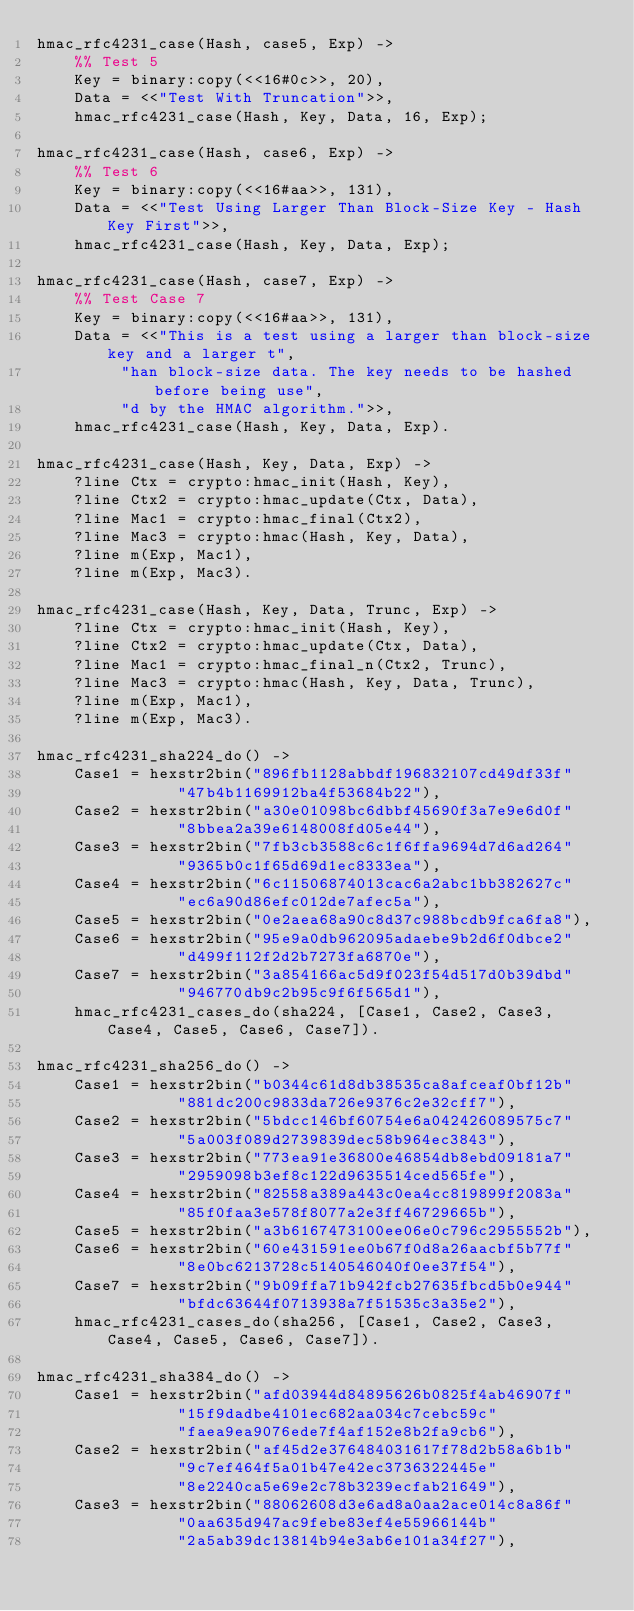<code> <loc_0><loc_0><loc_500><loc_500><_Erlang_>hmac_rfc4231_case(Hash, case5, Exp) ->
    %% Test 5
    Key = binary:copy(<<16#0c>>, 20),
    Data = <<"Test With Truncation">>,
    hmac_rfc4231_case(Hash, Key, Data, 16, Exp);

hmac_rfc4231_case(Hash, case6, Exp) ->
    %% Test 6
    Key = binary:copy(<<16#aa>>, 131),
    Data = <<"Test Using Larger Than Block-Size Key - Hash Key First">>,
    hmac_rfc4231_case(Hash, Key, Data, Exp);

hmac_rfc4231_case(Hash, case7, Exp) ->
    %% Test Case 7
    Key = binary:copy(<<16#aa>>, 131),
    Data = <<"This is a test using a larger than block-size key and a larger t",
	     "han block-size data. The key needs to be hashed before being use",
	     "d by the HMAC algorithm.">>,
    hmac_rfc4231_case(Hash, Key, Data, Exp).

hmac_rfc4231_case(Hash, Key, Data, Exp) ->
    ?line Ctx = crypto:hmac_init(Hash, Key),
    ?line Ctx2 = crypto:hmac_update(Ctx, Data),
    ?line Mac1 = crypto:hmac_final(Ctx2),
    ?line Mac3 = crypto:hmac(Hash, Key, Data),
    ?line m(Exp, Mac1),
    ?line m(Exp, Mac3).

hmac_rfc4231_case(Hash, Key, Data, Trunc, Exp) ->
    ?line Ctx = crypto:hmac_init(Hash, Key),
    ?line Ctx2 = crypto:hmac_update(Ctx, Data),
    ?line Mac1 = crypto:hmac_final_n(Ctx2, Trunc),
    ?line Mac3 = crypto:hmac(Hash, Key, Data, Trunc),
    ?line m(Exp, Mac1),
    ?line m(Exp, Mac3).

hmac_rfc4231_sha224_do() ->
    Case1 = hexstr2bin("896fb1128abbdf196832107cd49df33f"
		       "47b4b1169912ba4f53684b22"),
    Case2 = hexstr2bin("a30e01098bc6dbbf45690f3a7e9e6d0f"
		       "8bbea2a39e6148008fd05e44"),
    Case3 = hexstr2bin("7fb3cb3588c6c1f6ffa9694d7d6ad264"
		       "9365b0c1f65d69d1ec8333ea"),
    Case4 = hexstr2bin("6c11506874013cac6a2abc1bb382627c"
		       "ec6a90d86efc012de7afec5a"),
    Case5 = hexstr2bin("0e2aea68a90c8d37c988bcdb9fca6fa8"),
    Case6 = hexstr2bin("95e9a0db962095adaebe9b2d6f0dbce2"
		       "d499f112f2d2b7273fa6870e"),
    Case7 = hexstr2bin("3a854166ac5d9f023f54d517d0b39dbd"
		       "946770db9c2b95c9f6f565d1"),
    hmac_rfc4231_cases_do(sha224, [Case1, Case2, Case3, Case4, Case5, Case6, Case7]).

hmac_rfc4231_sha256_do() ->
    Case1 = hexstr2bin("b0344c61d8db38535ca8afceaf0bf12b"
		       "881dc200c9833da726e9376c2e32cff7"),
    Case2 = hexstr2bin("5bdcc146bf60754e6a042426089575c7"
		       "5a003f089d2739839dec58b964ec3843"),
    Case3 = hexstr2bin("773ea91e36800e46854db8ebd09181a7"
		       "2959098b3ef8c122d9635514ced565fe"),
    Case4 = hexstr2bin("82558a389a443c0ea4cc819899f2083a"
		       "85f0faa3e578f8077a2e3ff46729665b"),
    Case5 = hexstr2bin("a3b6167473100ee06e0c796c2955552b"),
    Case6 = hexstr2bin("60e431591ee0b67f0d8a26aacbf5b77f"
		       "8e0bc6213728c5140546040f0ee37f54"),
    Case7 = hexstr2bin("9b09ffa71b942fcb27635fbcd5b0e944"
		       "bfdc63644f0713938a7f51535c3a35e2"),
    hmac_rfc4231_cases_do(sha256, [Case1, Case2, Case3, Case4, Case5, Case6, Case7]).

hmac_rfc4231_sha384_do() ->
    Case1 = hexstr2bin("afd03944d84895626b0825f4ab46907f"
		       "15f9dadbe4101ec682aa034c7cebc59c"
		       "faea9ea9076ede7f4af152e8b2fa9cb6"),
    Case2 = hexstr2bin("af45d2e376484031617f78d2b58a6b1b"
		       "9c7ef464f5a01b47e42ec3736322445e"
		       "8e2240ca5e69e2c78b3239ecfab21649"),
    Case3 = hexstr2bin("88062608d3e6ad8a0aa2ace014c8a86f"
		       "0aa635d947ac9febe83ef4e55966144b"
		       "2a5ab39dc13814b94e3ab6e101a34f27"),</code> 